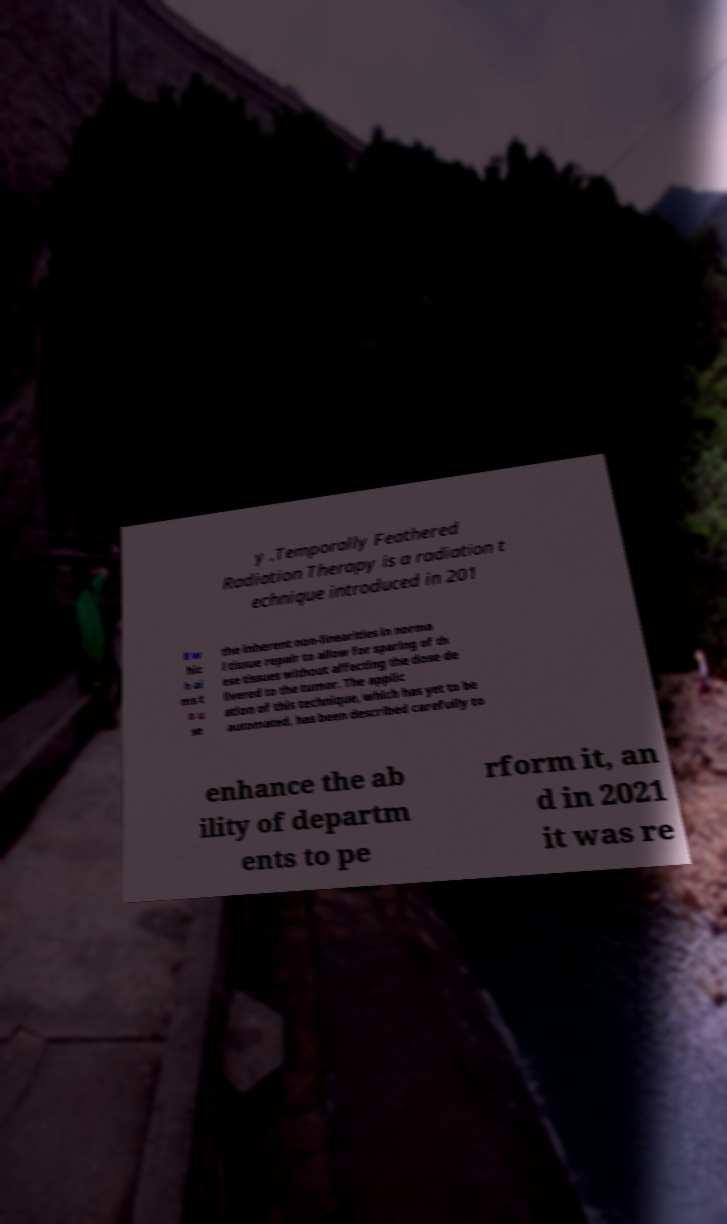Can you read and provide the text displayed in the image?This photo seems to have some interesting text. Can you extract and type it out for me? y .Temporally Feathered Radiation Therapy is a radiation t echnique introduced in 201 8 w hic h ai ms t o u se the inherent non-linearities in norma l tissue repair to allow for sparing of th ese tissues without affecting the dose de livered to the tumor. The applic ation of this technique, which has yet to be automated, has been described carefully to enhance the ab ility of departm ents to pe rform it, an d in 2021 it was re 